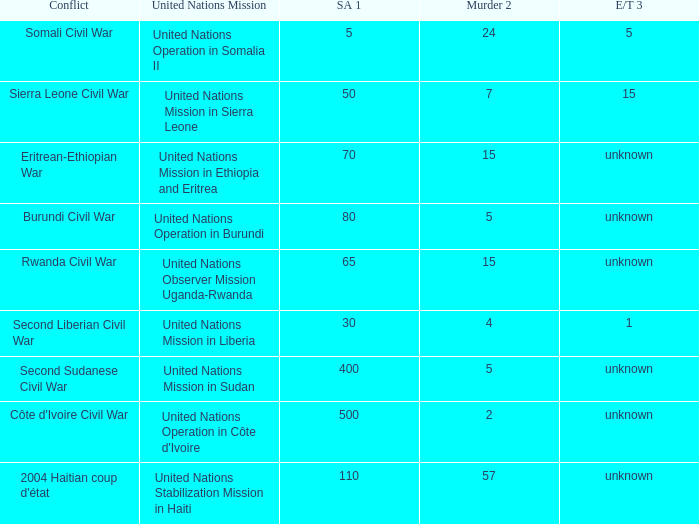I'm looking to parse the entire table for insights. Could you assist me with that? {'header': ['Conflict', 'United Nations Mission', 'SA 1', 'Murder 2', 'E/T 3'], 'rows': [['Somali Civil War', 'United Nations Operation in Somalia II', '5', '24', '5'], ['Sierra Leone Civil War', 'United Nations Mission in Sierra Leone', '50', '7', '15'], ['Eritrean-Ethiopian War', 'United Nations Mission in Ethiopia and Eritrea', '70', '15', 'unknown'], ['Burundi Civil War', 'United Nations Operation in Burundi', '80', '5', 'unknown'], ['Rwanda Civil War', 'United Nations Observer Mission Uganda-Rwanda', '65', '15', 'unknown'], ['Second Liberian Civil War', 'United Nations Mission in Liberia', '30', '4', '1'], ['Second Sudanese Civil War', 'United Nations Mission in Sudan', '400', '5', 'unknown'], ["Côte d'Ivoire Civil War", "United Nations Operation in Côte d'Ivoire", '500', '2', 'unknown'], ["2004 Haitian coup d'état", 'United Nations Stabilization Mission in Haiti', '110', '57', 'unknown']]} What is the sexual abuse rate where the conflict is the Burundi Civil War? 80.0. 